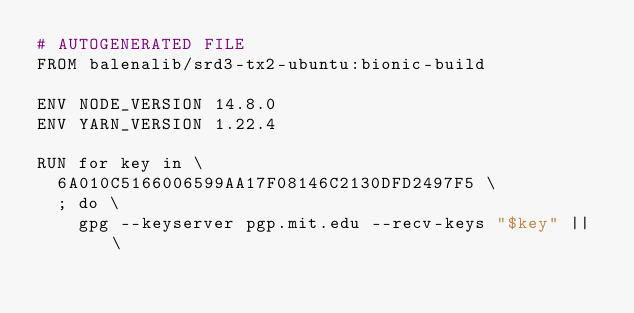Convert code to text. <code><loc_0><loc_0><loc_500><loc_500><_Dockerfile_># AUTOGENERATED FILE
FROM balenalib/srd3-tx2-ubuntu:bionic-build

ENV NODE_VERSION 14.8.0
ENV YARN_VERSION 1.22.4

RUN for key in \
	6A010C5166006599AA17F08146C2130DFD2497F5 \
	; do \
		gpg --keyserver pgp.mit.edu --recv-keys "$key" || \</code> 